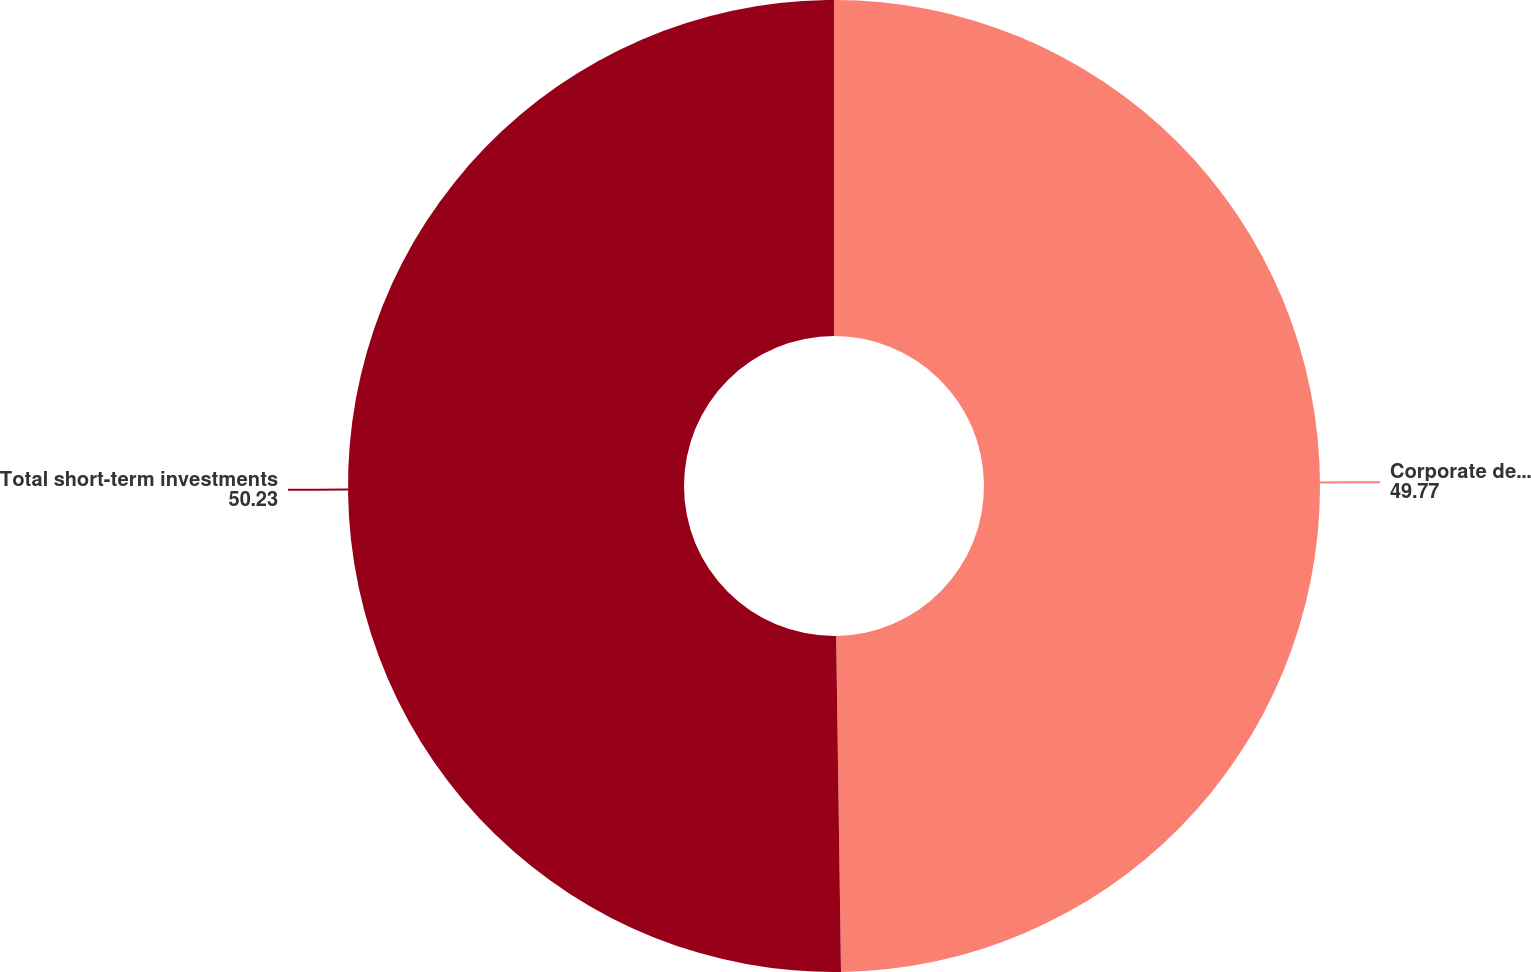Convert chart to OTSL. <chart><loc_0><loc_0><loc_500><loc_500><pie_chart><fcel>Corporate debt securities<fcel>Total short-term investments<nl><fcel>49.77%<fcel>50.23%<nl></chart> 